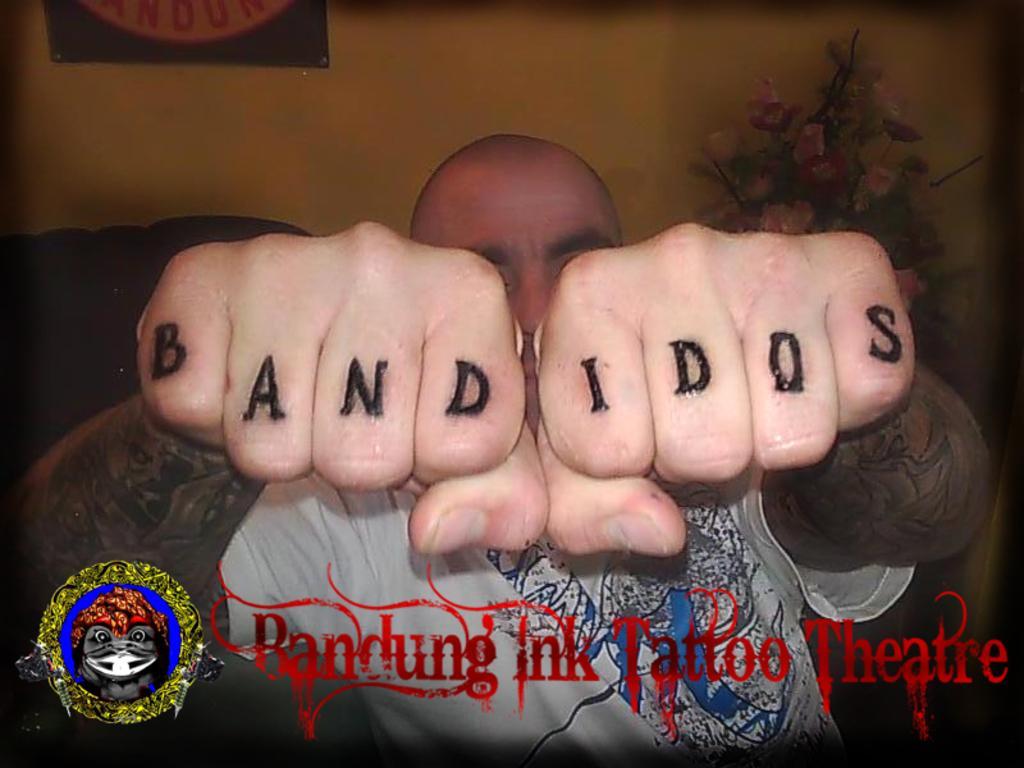Could you give a brief overview of what you see in this image? In the center of the image there is a person and there is some text on the knuckles. At the bottom of the image there is text. In the background of the image there is wall. To the right side of the image there are flowers. 